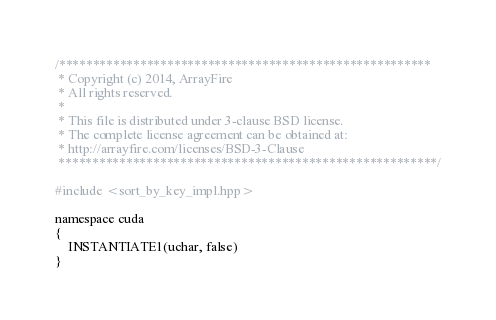Convert code to text. <code><loc_0><loc_0><loc_500><loc_500><_Cuda_>/*******************************************************
 * Copyright (c) 2014, ArrayFire
 * All rights reserved.
 *
 * This file is distributed under 3-clause BSD license.
 * The complete license agreement can be obtained at:
 * http://arrayfire.com/licenses/BSD-3-Clause
 ********************************************************/

#include <sort_by_key_impl.hpp>

namespace cuda
{
    INSTANTIATE1(uchar, false)
}
</code> 